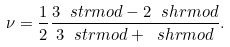<formula> <loc_0><loc_0><loc_500><loc_500>\nu = \frac { 1 } { 2 } \frac { 3 \ s t r m o d - 2 \ s h r m o d } { 3 \ s t r m o d + \ s h r m o d } .</formula> 